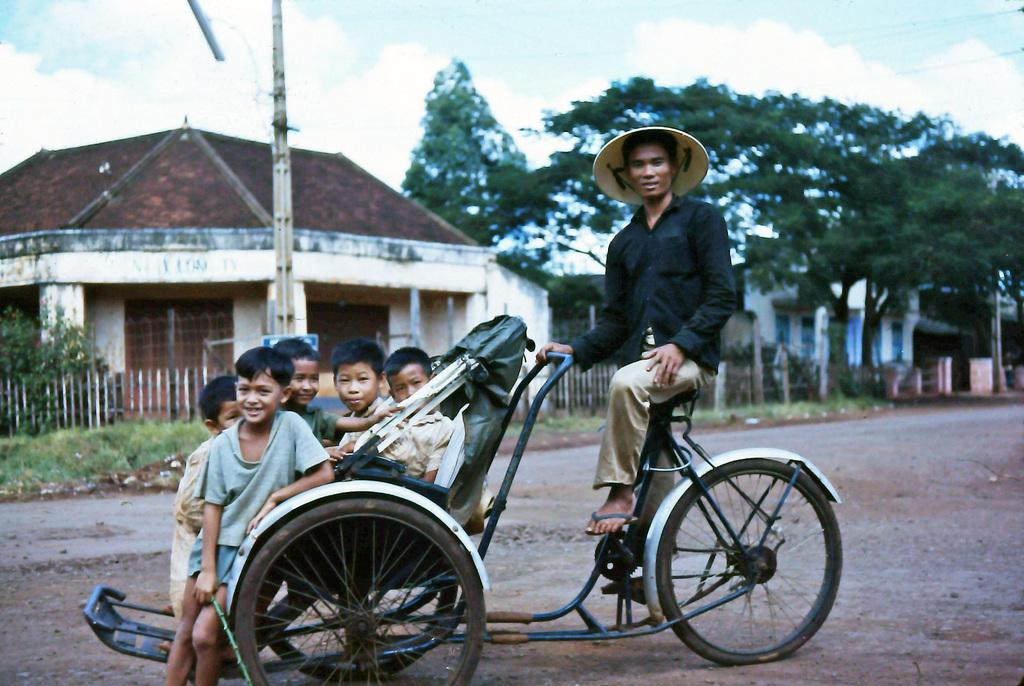How many boys are in the image? There are five boys in the image. Where are the boys sitting in the image? The boys are sitting on a wheelchair carrier. Who else is in the image besides the boys? There is a man in the image. Where is the man sitting in the image? The man is sitting on a wheelchair seat. What can be seen in the background of the image? There is a house and trees in the background of the image. What type of jewel is the stranger wearing in the image? There is no stranger present in the image, and therefore no one is wearing any jewels. 